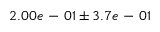Convert formula to latex. <formula><loc_0><loc_0><loc_500><loc_500>2 . 0 0 e - 0 1 \pm 3 . 7 e - 0 1</formula> 